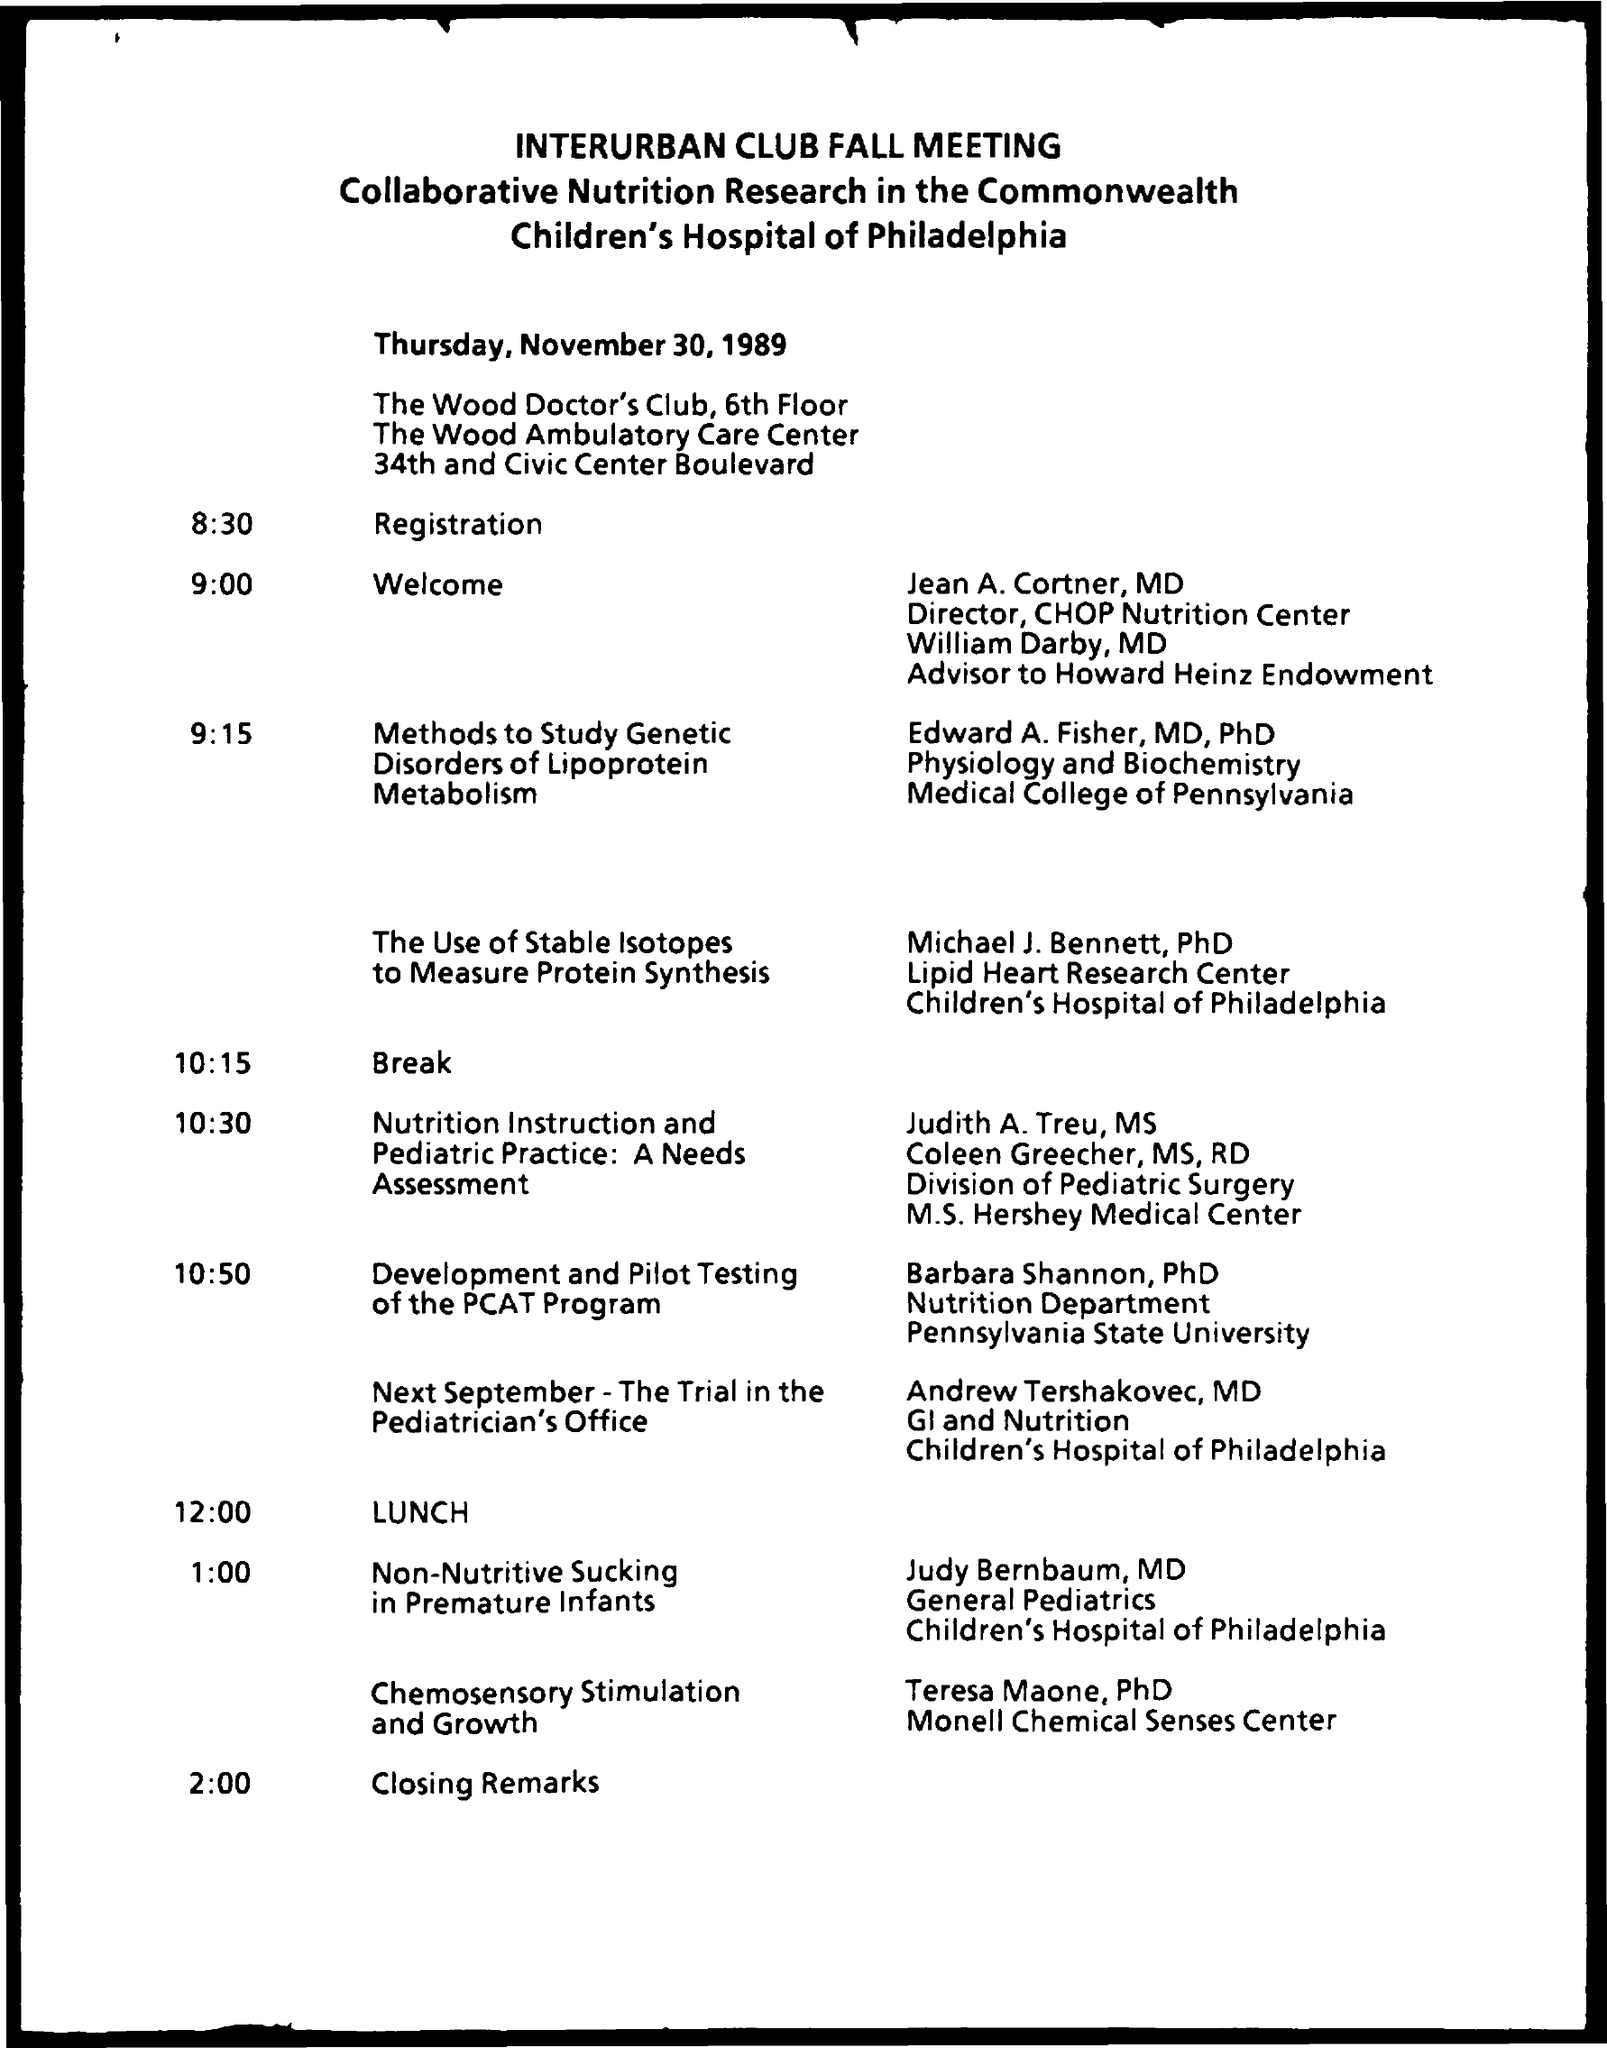What was the final presentation about? The final presentation according to the schedule at 1:00 PM by Teresa Maone, PhD, was on 'Chemosensory Stimulation and Growth'. It was part of the Interurban Club Fall Meeting's series of scientific talks on nutrition and was associated with the Monell Chemical Senses Center.  Was the event spanning multiple days? Based on the schedule in the image, the event was a one-day meeting taking place on Thursday, November 30, 1989. The agenda is full of presentations and discussions, concluding with closing remarks at 2:00 PM. 